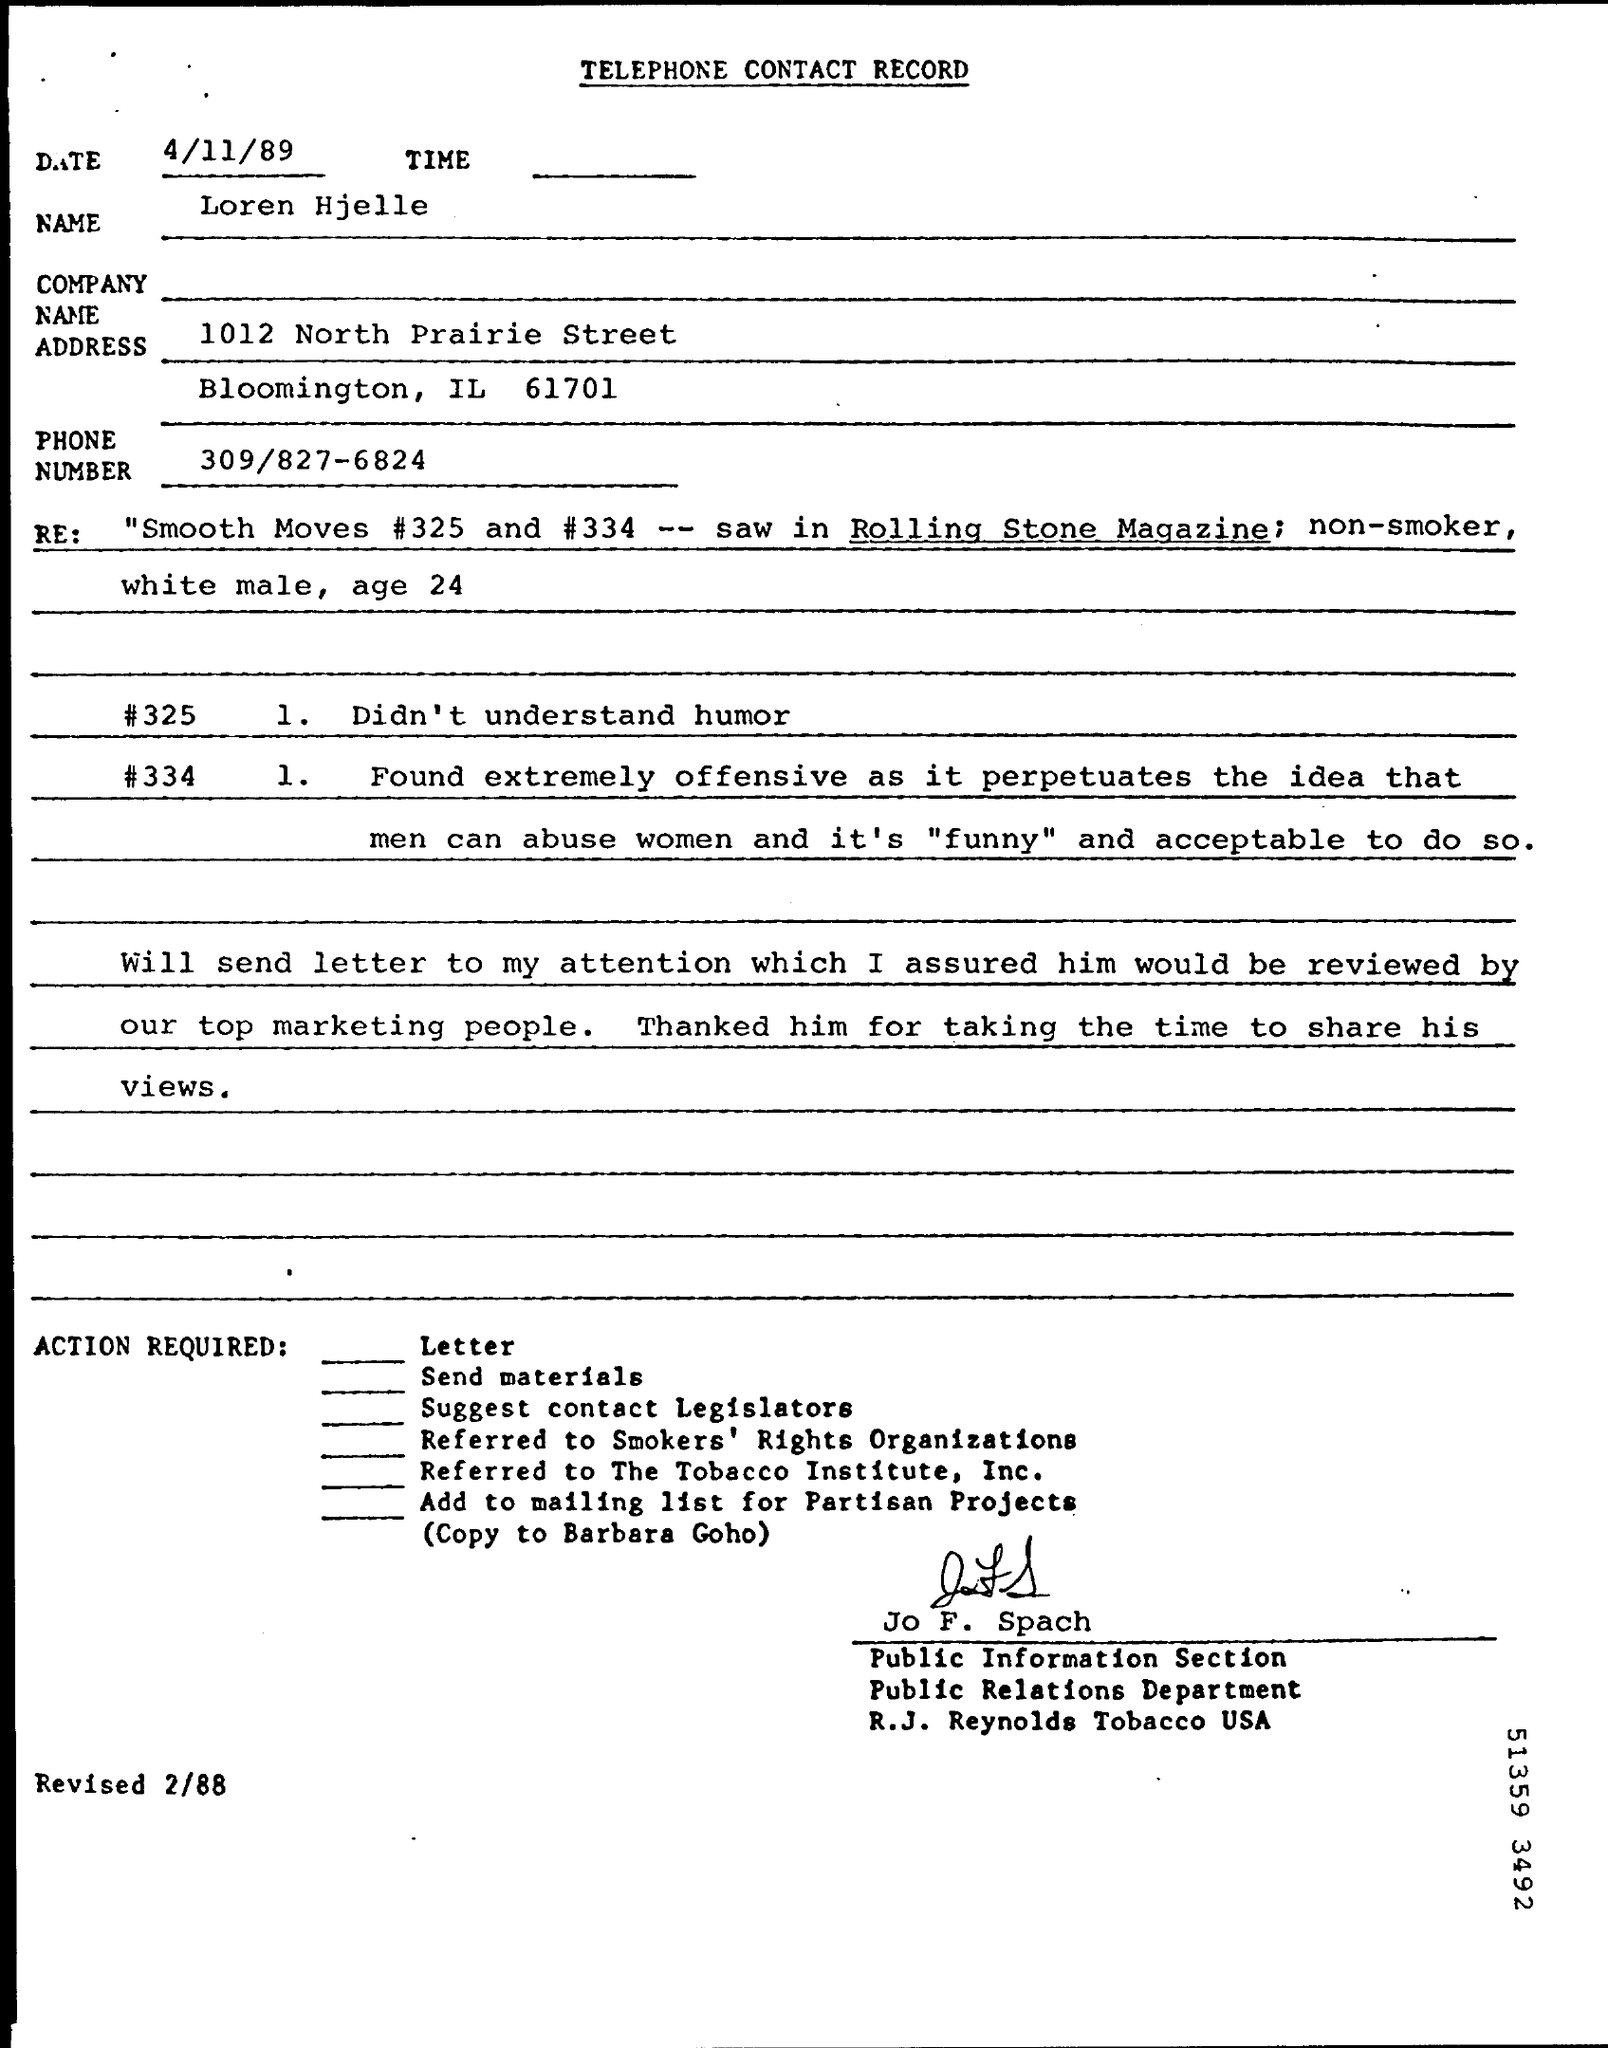what is the age mentioned in the Re:
 24 